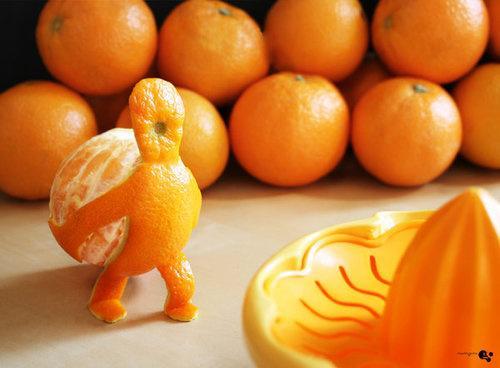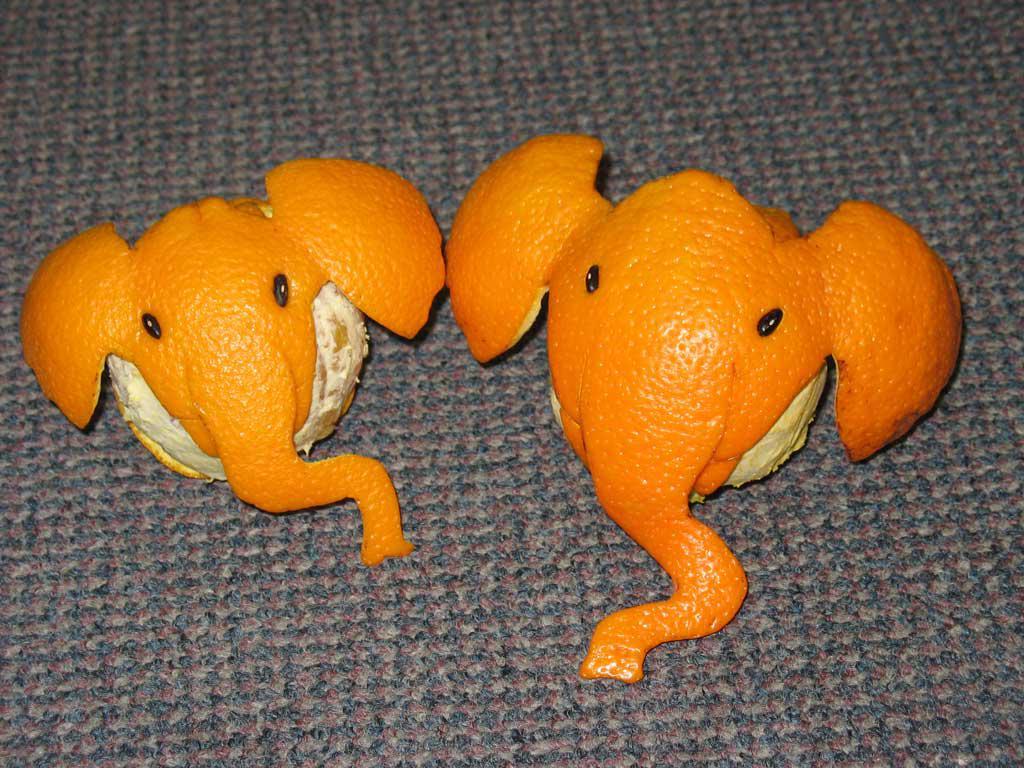The first image is the image on the left, the second image is the image on the right. Analyze the images presented: Is the assertion "In one of the images, the orange peel looks like a man that is carrying the orange as it walks." valid? Answer yes or no. Yes. The first image is the image on the left, the second image is the image on the right. Evaluate the accuracy of this statement regarding the images: "there is an orange peeled in a way that it looks like a person carrying a ball". Is it true? Answer yes or no. Yes. 